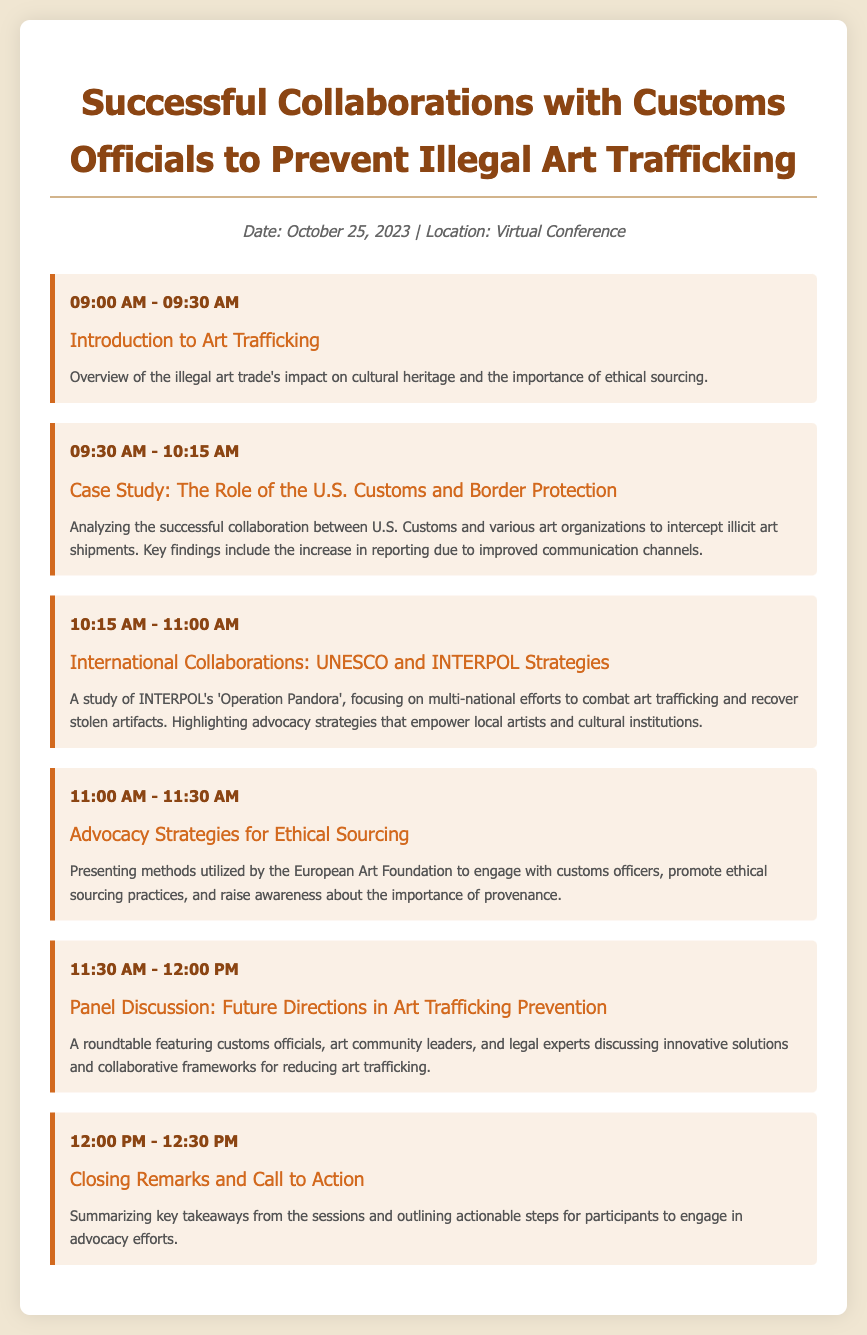What is the date of the virtual conference? The date of the virtual conference is explicitly stated in the document.
Answer: October 25, 2023 What is the title of the case study presented at 09:30 AM? The title of the case study is listed in the session header, providing specific information.
Answer: Case Study: The Role of the U.S. Customs and Border Protection Which operation is associated with INTERPOL's efforts against art trafficking? The name of the operation is clearly mentioned in the document, reflecting the partnership's focus.
Answer: Operation Pandora What organization conducted advocacy strategies for ethical sourcing? The organization involved in the advocacy strategies is noted in the session description.
Answer: European Art Foundation What is one key finding from the U.S. Customs case study? The key finding regarding the collaboration's impact is detailed in the case study description.
Answer: Increase in reporting What time does the panel discussion take place? The time of the panel discussion is provided in the session structure, indicating when it occurs.
Answer: 11:30 AM - 12:00 PM What is the primary focus of the introduction session? The primary focus of the introduction session is summarized in its description, showing its main theme.
Answer: Impact on cultural heritage What is the goal of the closing remarks session? The goal of the closing remarks is outlined in the session description, indicating its purpose.
Answer: Call to Action 